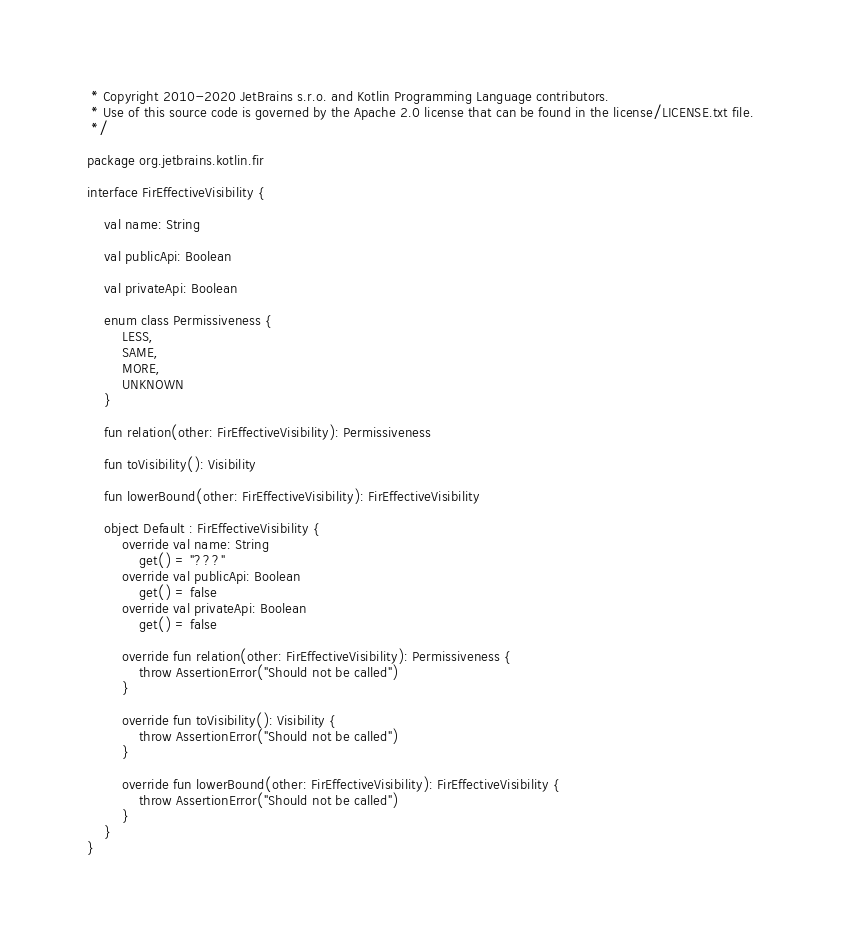Convert code to text. <code><loc_0><loc_0><loc_500><loc_500><_Kotlin_> * Copyright 2010-2020 JetBrains s.r.o. and Kotlin Programming Language contributors.
 * Use of this source code is governed by the Apache 2.0 license that can be found in the license/LICENSE.txt file.
 */

package org.jetbrains.kotlin.fir

interface FirEffectiveVisibility {

    val name: String

    val publicApi: Boolean

    val privateApi: Boolean

    enum class Permissiveness {
        LESS,
        SAME,
        MORE,
        UNKNOWN
    }

    fun relation(other: FirEffectiveVisibility): Permissiveness

    fun toVisibility(): Visibility

    fun lowerBound(other: FirEffectiveVisibility): FirEffectiveVisibility

    object Default : FirEffectiveVisibility {
        override val name: String
            get() = "???"
        override val publicApi: Boolean
            get() = false
        override val privateApi: Boolean
            get() = false

        override fun relation(other: FirEffectiveVisibility): Permissiveness {
            throw AssertionError("Should not be called")
        }

        override fun toVisibility(): Visibility {
            throw AssertionError("Should not be called")
        }

        override fun lowerBound(other: FirEffectiveVisibility): FirEffectiveVisibility {
            throw AssertionError("Should not be called")
        }
    }
}

</code> 